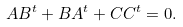Convert formula to latex. <formula><loc_0><loc_0><loc_500><loc_500>A B ^ { t } + B A ^ { t } + C C ^ { t } = 0 .</formula> 